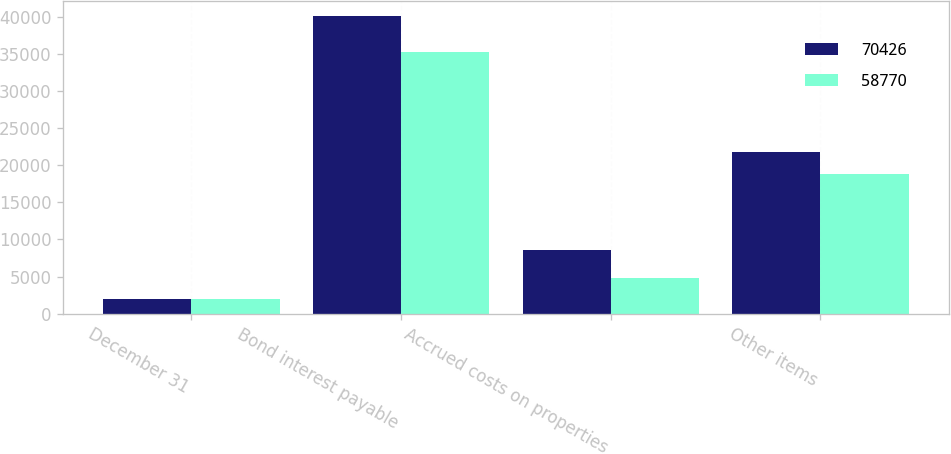<chart> <loc_0><loc_0><loc_500><loc_500><stacked_bar_chart><ecel><fcel>December 31<fcel>Bond interest payable<fcel>Accrued costs on properties<fcel>Other items<nl><fcel>70426<fcel>2012<fcel>40061<fcel>8595<fcel>21770<nl><fcel>58770<fcel>2011<fcel>35195<fcel>4766<fcel>18809<nl></chart> 